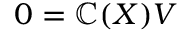Convert formula to latex. <formula><loc_0><loc_0><loc_500><loc_500>0 = \mathbb { C } ( X ) V</formula> 